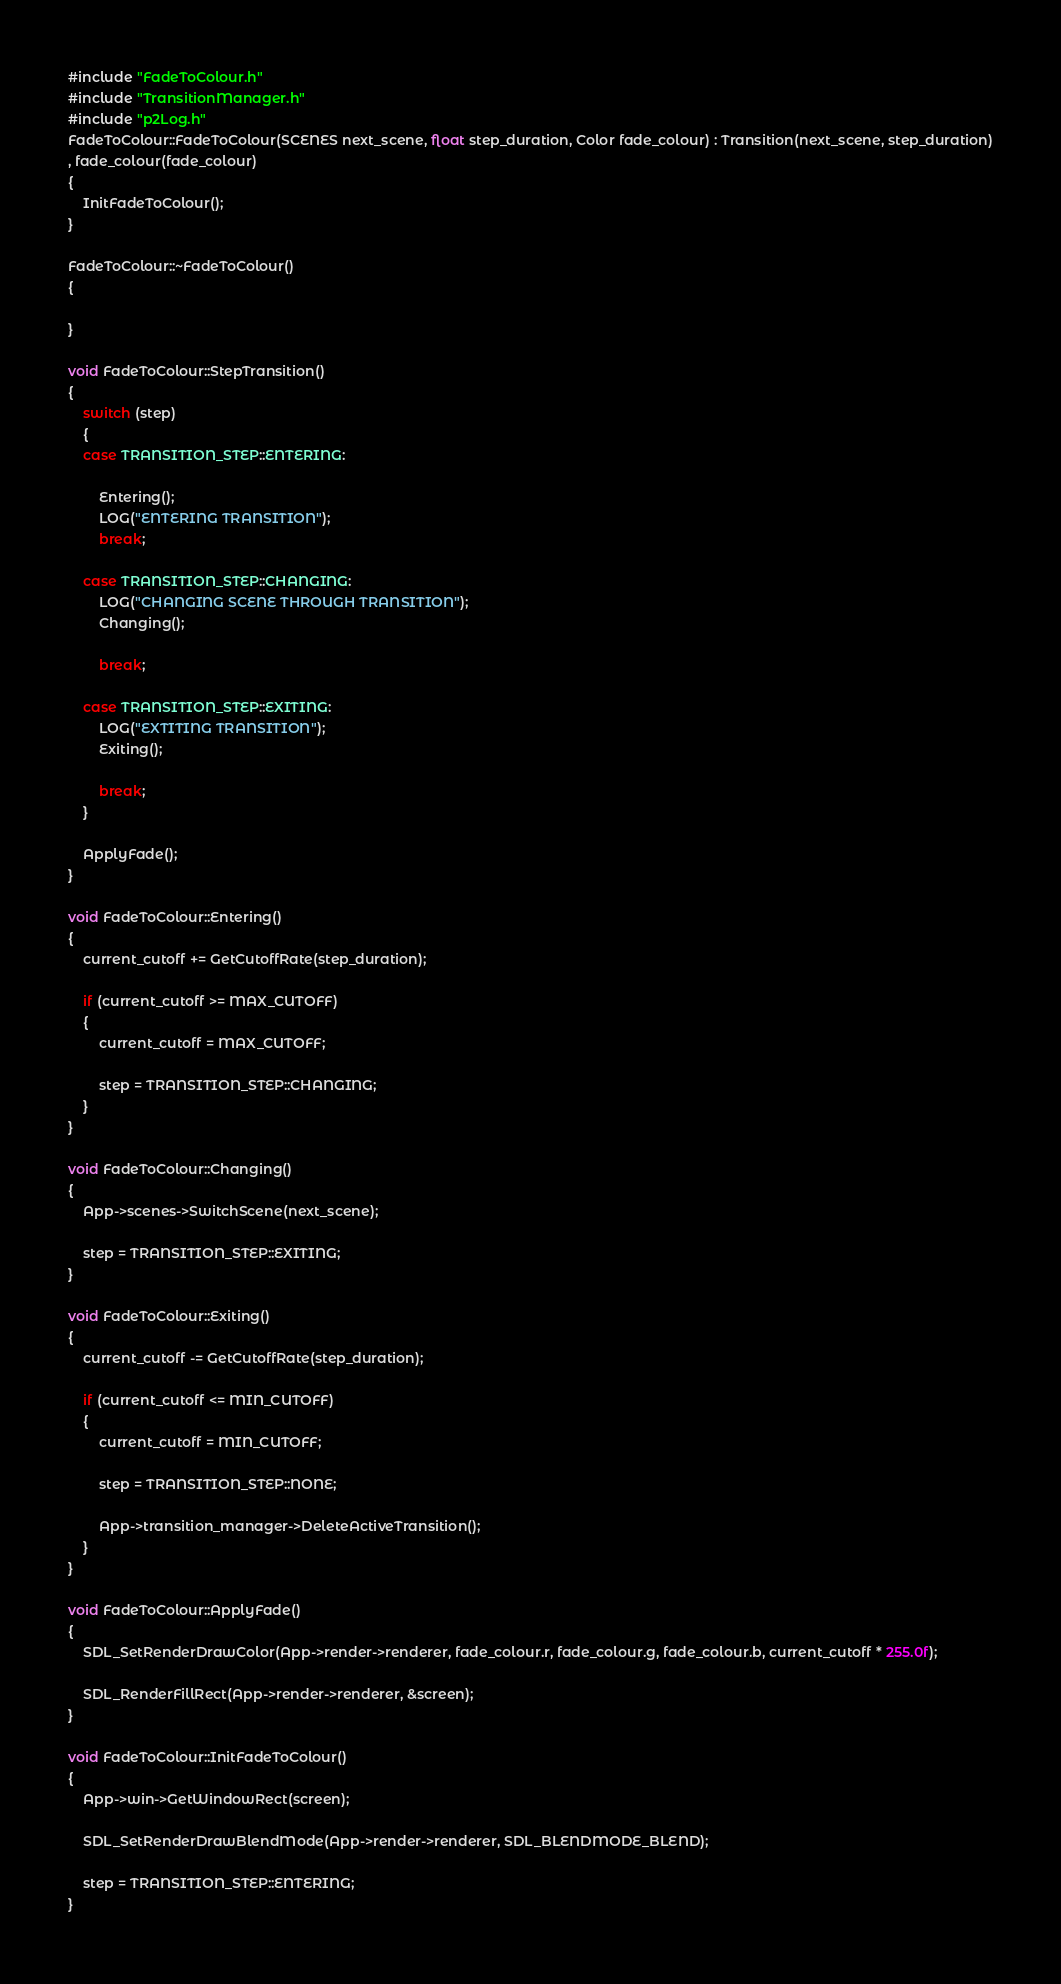Convert code to text. <code><loc_0><loc_0><loc_500><loc_500><_C++_>#include "FadeToColour.h"
#include "TransitionManager.h"
#include "p2Log.h"
FadeToColour::FadeToColour(SCENES next_scene, float step_duration, Color fade_colour) : Transition(next_scene, step_duration)
, fade_colour(fade_colour)
{	
	InitFadeToColour();
}

FadeToColour::~FadeToColour()
{

}

void FadeToColour::StepTransition()
{
	switch (step)
	{
	case TRANSITION_STEP::ENTERING:
		
		Entering();
		LOG("ENTERING TRANSITION");
		break;

	case TRANSITION_STEP::CHANGING:
		LOG("CHANGING SCENE THROUGH TRANSITION");
		Changing();

		break;

	case TRANSITION_STEP::EXITING:
		LOG("EXTITING TRANSITION");
		Exiting();
		
		break;
	}

	ApplyFade();
}

void FadeToColour::Entering()
{
	current_cutoff += GetCutoffRate(step_duration);

	if (current_cutoff >= MAX_CUTOFF)
	{
		current_cutoff = MAX_CUTOFF;

		step = TRANSITION_STEP::CHANGING;
	}
}

void FadeToColour::Changing()
{
	App->scenes->SwitchScene(next_scene);

	step = TRANSITION_STEP::EXITING;
}

void FadeToColour::Exiting()
{
	current_cutoff -= GetCutoffRate(step_duration);

	if (current_cutoff <= MIN_CUTOFF)
	{
		current_cutoff = MIN_CUTOFF;

		step = TRANSITION_STEP::NONE;

		App->transition_manager->DeleteActiveTransition();
	}
}

void FadeToColour::ApplyFade()
{
	SDL_SetRenderDrawColor(App->render->renderer, fade_colour.r, fade_colour.g, fade_colour.b, current_cutoff * 255.0f);

	SDL_RenderFillRect(App->render->renderer, &screen);
}

void FadeToColour::InitFadeToColour()
{
	App->win->GetWindowRect(screen);

	SDL_SetRenderDrawBlendMode(App->render->renderer, SDL_BLENDMODE_BLEND);

	step = TRANSITION_STEP::ENTERING;
}</code> 